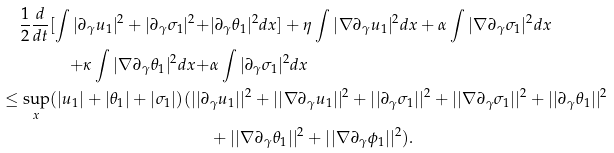<formula> <loc_0><loc_0><loc_500><loc_500>\frac { 1 } { 2 } \frac { d } { d t } [ \int | \partial _ { \gamma } u _ { 1 } | ^ { 2 } + | \partial _ { \gamma } \sigma _ { 1 } | ^ { 2 } + & | \partial _ { \gamma } \theta _ { 1 } | ^ { 2 } d x ] + \eta \int | \nabla \partial _ { \gamma } u _ { 1 } | ^ { 2 } d x + \alpha \int | \nabla \partial _ { \gamma } \sigma _ { 1 } | ^ { 2 } d x \\ + \kappa \int | \nabla \partial _ { \gamma } \theta _ { 1 } | ^ { 2 } d x + & \alpha \int | \partial _ { \gamma } \sigma _ { 1 } | ^ { 2 } d x \\ \leq \sup _ { x } ( | u _ { 1 } | + | \theta _ { 1 } | + | \sigma _ { 1 } | ) ( | | \partial & _ { \gamma } u _ { 1 } | | ^ { 2 } + | | \nabla \partial _ { \gamma } u _ { 1 } | | ^ { 2 } + | | \partial _ { \gamma } \sigma _ { 1 } | | ^ { 2 } + | | \nabla \partial _ { \gamma } \sigma _ { 1 } | | ^ { 2 } + | | \partial _ { \gamma } \theta _ { 1 } | | ^ { 2 } \\ & + | | \nabla \partial _ { \gamma } \theta _ { 1 } | | ^ { 2 } + | | \nabla \partial _ { \gamma } \phi _ { 1 } | | ^ { 2 } ) .</formula> 